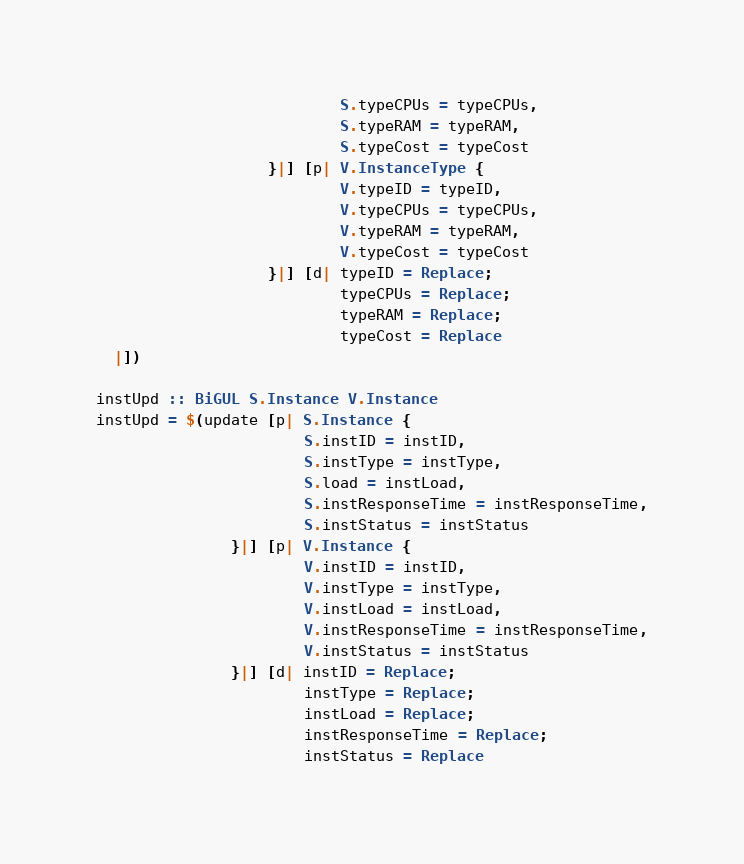<code> <loc_0><loc_0><loc_500><loc_500><_Haskell_>                           S.typeCPUs = typeCPUs,
                           S.typeRAM = typeRAM,
                           S.typeCost = typeCost
                   }|] [p| V.InstanceType {
                           V.typeID = typeID,
                           V.typeCPUs = typeCPUs,
                           V.typeRAM = typeRAM,
                           V.typeCost = typeCost
                   }|] [d| typeID = Replace;
                           typeCPUs = Replace;
                           typeRAM = Replace;
                           typeCost = Replace
  |])

instUpd :: BiGUL S.Instance V.Instance
instUpd = $(update [p| S.Instance {
                       S.instID = instID,
                       S.instType = instType,
                       S.load = instLoad,
                       S.instResponseTime = instResponseTime,
                       S.instStatus = instStatus
               }|] [p| V.Instance {
                       V.instID = instID,
                       V.instType = instType,
                       V.instLoad = instLoad,
                       V.instResponseTime = instResponseTime,
                       V.instStatus = instStatus
               }|] [d| instID = Replace;
                       instType = Replace;
                       instLoad = Replace;
                       instResponseTime = Replace;
                       instStatus = Replace</code> 